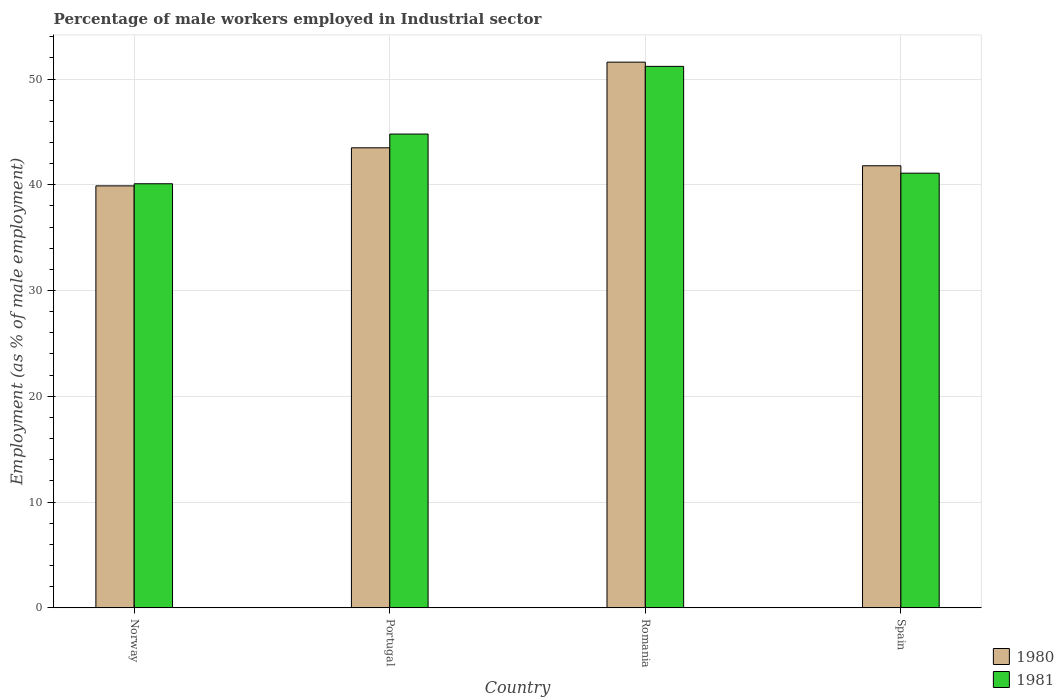How many different coloured bars are there?
Keep it short and to the point. 2. How many groups of bars are there?
Make the answer very short. 4. How many bars are there on the 2nd tick from the left?
Your response must be concise. 2. In how many cases, is the number of bars for a given country not equal to the number of legend labels?
Offer a terse response. 0. What is the percentage of male workers employed in Industrial sector in 1980 in Romania?
Provide a succinct answer. 51.6. Across all countries, what is the maximum percentage of male workers employed in Industrial sector in 1980?
Keep it short and to the point. 51.6. Across all countries, what is the minimum percentage of male workers employed in Industrial sector in 1981?
Your answer should be compact. 40.1. In which country was the percentage of male workers employed in Industrial sector in 1980 maximum?
Your response must be concise. Romania. What is the total percentage of male workers employed in Industrial sector in 1981 in the graph?
Offer a terse response. 177.2. What is the difference between the percentage of male workers employed in Industrial sector in 1980 in Norway and that in Romania?
Provide a short and direct response. -11.7. What is the difference between the percentage of male workers employed in Industrial sector in 1980 in Portugal and the percentage of male workers employed in Industrial sector in 1981 in Norway?
Your answer should be very brief. 3.4. What is the average percentage of male workers employed in Industrial sector in 1981 per country?
Provide a succinct answer. 44.3. What is the difference between the percentage of male workers employed in Industrial sector of/in 1981 and percentage of male workers employed in Industrial sector of/in 1980 in Norway?
Provide a succinct answer. 0.2. What is the ratio of the percentage of male workers employed in Industrial sector in 1981 in Portugal to that in Spain?
Give a very brief answer. 1.09. What is the difference between the highest and the second highest percentage of male workers employed in Industrial sector in 1980?
Give a very brief answer. -8.1. What is the difference between the highest and the lowest percentage of male workers employed in Industrial sector in 1981?
Offer a very short reply. 11.1. In how many countries, is the percentage of male workers employed in Industrial sector in 1980 greater than the average percentage of male workers employed in Industrial sector in 1980 taken over all countries?
Your answer should be compact. 1. Is the sum of the percentage of male workers employed in Industrial sector in 1981 in Romania and Spain greater than the maximum percentage of male workers employed in Industrial sector in 1980 across all countries?
Offer a very short reply. Yes. What does the 1st bar from the right in Norway represents?
Make the answer very short. 1981. How many bars are there?
Give a very brief answer. 8. Are all the bars in the graph horizontal?
Provide a succinct answer. No. How many countries are there in the graph?
Your answer should be very brief. 4. Does the graph contain grids?
Offer a very short reply. Yes. How are the legend labels stacked?
Give a very brief answer. Vertical. What is the title of the graph?
Your answer should be very brief. Percentage of male workers employed in Industrial sector. What is the label or title of the Y-axis?
Your answer should be compact. Employment (as % of male employment). What is the Employment (as % of male employment) of 1980 in Norway?
Offer a terse response. 39.9. What is the Employment (as % of male employment) of 1981 in Norway?
Offer a terse response. 40.1. What is the Employment (as % of male employment) of 1980 in Portugal?
Keep it short and to the point. 43.5. What is the Employment (as % of male employment) of 1981 in Portugal?
Give a very brief answer. 44.8. What is the Employment (as % of male employment) in 1980 in Romania?
Provide a short and direct response. 51.6. What is the Employment (as % of male employment) of 1981 in Romania?
Provide a succinct answer. 51.2. What is the Employment (as % of male employment) of 1980 in Spain?
Provide a succinct answer. 41.8. What is the Employment (as % of male employment) in 1981 in Spain?
Give a very brief answer. 41.1. Across all countries, what is the maximum Employment (as % of male employment) of 1980?
Your answer should be compact. 51.6. Across all countries, what is the maximum Employment (as % of male employment) of 1981?
Your answer should be very brief. 51.2. Across all countries, what is the minimum Employment (as % of male employment) of 1980?
Make the answer very short. 39.9. Across all countries, what is the minimum Employment (as % of male employment) in 1981?
Provide a succinct answer. 40.1. What is the total Employment (as % of male employment) of 1980 in the graph?
Your response must be concise. 176.8. What is the total Employment (as % of male employment) in 1981 in the graph?
Your answer should be compact. 177.2. What is the difference between the Employment (as % of male employment) of 1980 in Norway and that in Spain?
Your answer should be compact. -1.9. What is the difference between the Employment (as % of male employment) of 1981 in Portugal and that in Romania?
Your answer should be compact. -6.4. What is the difference between the Employment (as % of male employment) of 1981 in Portugal and that in Spain?
Make the answer very short. 3.7. What is the difference between the Employment (as % of male employment) of 1980 in Norway and the Employment (as % of male employment) of 1981 in Portugal?
Provide a succinct answer. -4.9. What is the difference between the Employment (as % of male employment) in 1980 in Norway and the Employment (as % of male employment) in 1981 in Spain?
Your response must be concise. -1.2. What is the difference between the Employment (as % of male employment) of 1980 in Portugal and the Employment (as % of male employment) of 1981 in Spain?
Give a very brief answer. 2.4. What is the average Employment (as % of male employment) of 1980 per country?
Your response must be concise. 44.2. What is the average Employment (as % of male employment) of 1981 per country?
Keep it short and to the point. 44.3. What is the difference between the Employment (as % of male employment) in 1980 and Employment (as % of male employment) in 1981 in Portugal?
Give a very brief answer. -1.3. What is the ratio of the Employment (as % of male employment) in 1980 in Norway to that in Portugal?
Ensure brevity in your answer.  0.92. What is the ratio of the Employment (as % of male employment) of 1981 in Norway to that in Portugal?
Offer a terse response. 0.9. What is the ratio of the Employment (as % of male employment) of 1980 in Norway to that in Romania?
Provide a succinct answer. 0.77. What is the ratio of the Employment (as % of male employment) in 1981 in Norway to that in Romania?
Your response must be concise. 0.78. What is the ratio of the Employment (as % of male employment) in 1980 in Norway to that in Spain?
Offer a terse response. 0.95. What is the ratio of the Employment (as % of male employment) in 1981 in Norway to that in Spain?
Offer a very short reply. 0.98. What is the ratio of the Employment (as % of male employment) in 1980 in Portugal to that in Romania?
Your response must be concise. 0.84. What is the ratio of the Employment (as % of male employment) of 1980 in Portugal to that in Spain?
Your answer should be compact. 1.04. What is the ratio of the Employment (as % of male employment) of 1981 in Portugal to that in Spain?
Ensure brevity in your answer.  1.09. What is the ratio of the Employment (as % of male employment) in 1980 in Romania to that in Spain?
Ensure brevity in your answer.  1.23. What is the ratio of the Employment (as % of male employment) of 1981 in Romania to that in Spain?
Ensure brevity in your answer.  1.25. What is the difference between the highest and the second highest Employment (as % of male employment) in 1981?
Keep it short and to the point. 6.4. What is the difference between the highest and the lowest Employment (as % of male employment) in 1980?
Make the answer very short. 11.7. 